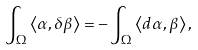Convert formula to latex. <formula><loc_0><loc_0><loc_500><loc_500>\int _ { \Omega } \left \langle \alpha , \delta \beta \right \rangle = - \int _ { \Omega } \left \langle d \alpha , \beta \right \rangle ,</formula> 